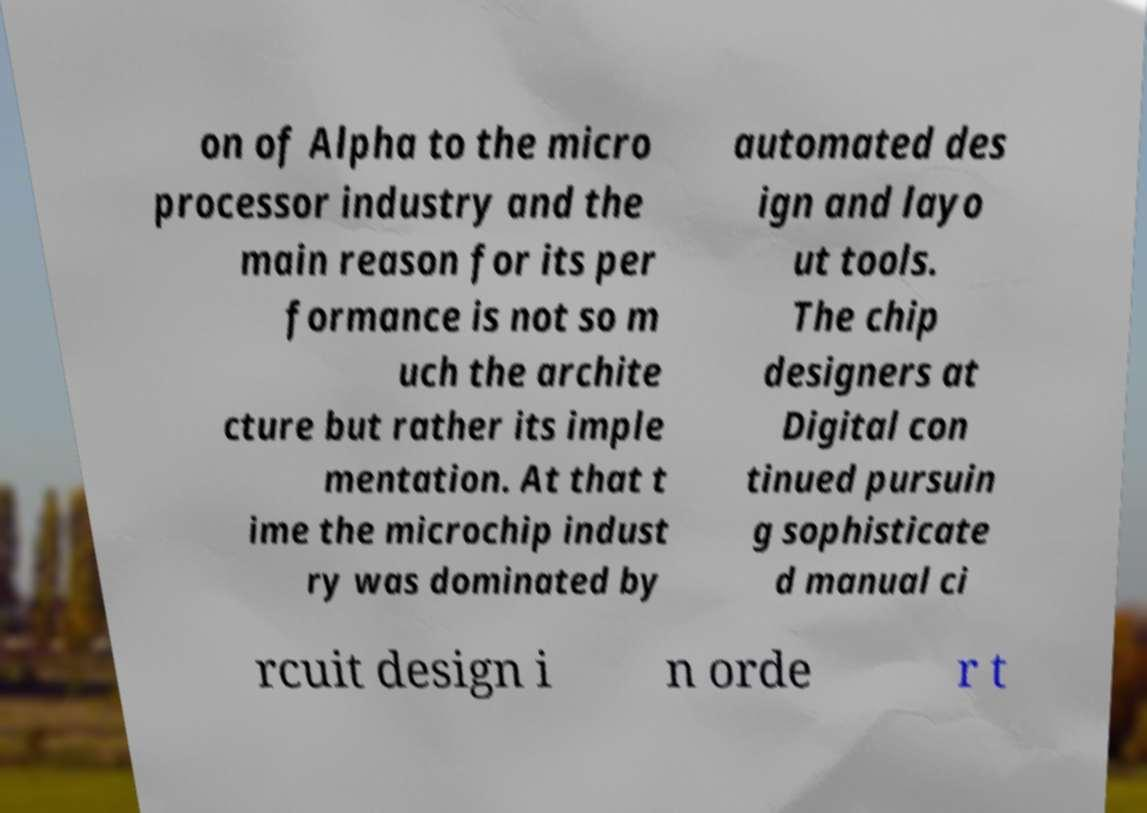Please identify and transcribe the text found in this image. on of Alpha to the micro processor industry and the main reason for its per formance is not so m uch the archite cture but rather its imple mentation. At that t ime the microchip indust ry was dominated by automated des ign and layo ut tools. The chip designers at Digital con tinued pursuin g sophisticate d manual ci rcuit design i n orde r t 